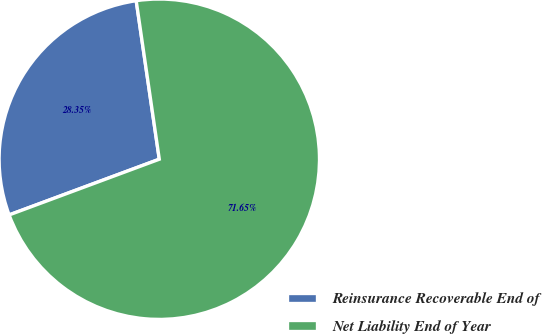Convert chart. <chart><loc_0><loc_0><loc_500><loc_500><pie_chart><fcel>Reinsurance Recoverable End of<fcel>Net Liability End of Year<nl><fcel>28.35%<fcel>71.65%<nl></chart> 